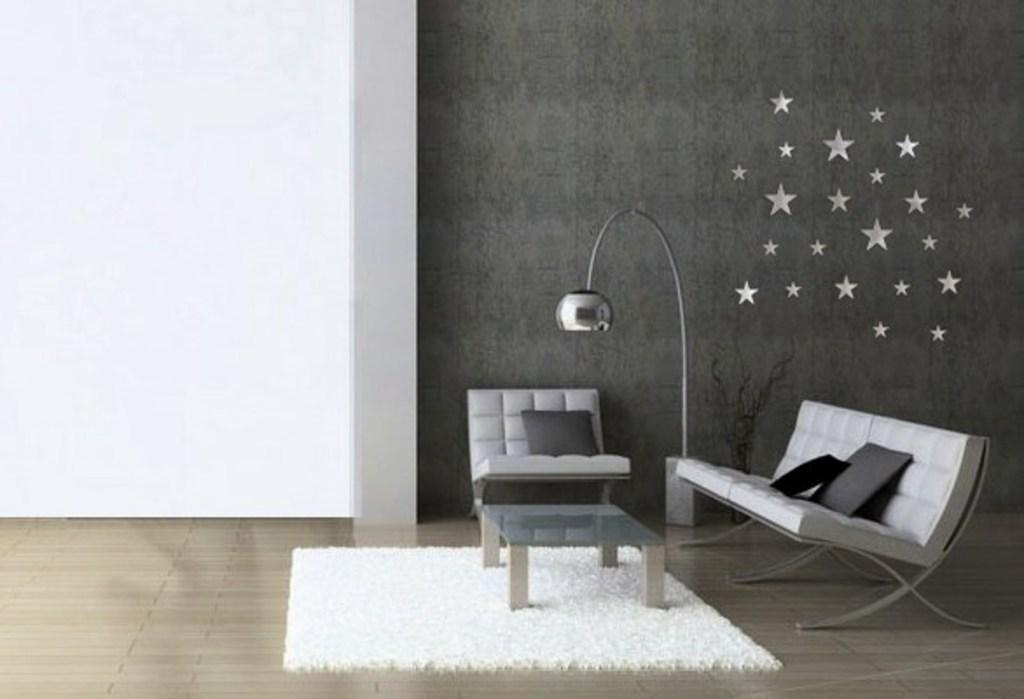What type of furniture is present in the image? There is a chair and a sofa in the image. What other objects can be seen in the image? There is a lamp in the image. Are there any decorations visible in the image? Yes, there are stars-shaped decorations on the wall. What color is the dress worn by the ear in the image? There is no ear or dress present in the image. Can you describe the zipper on the stars-shaped decorations? There are no zippers on the stars-shaped decorations in the image. 